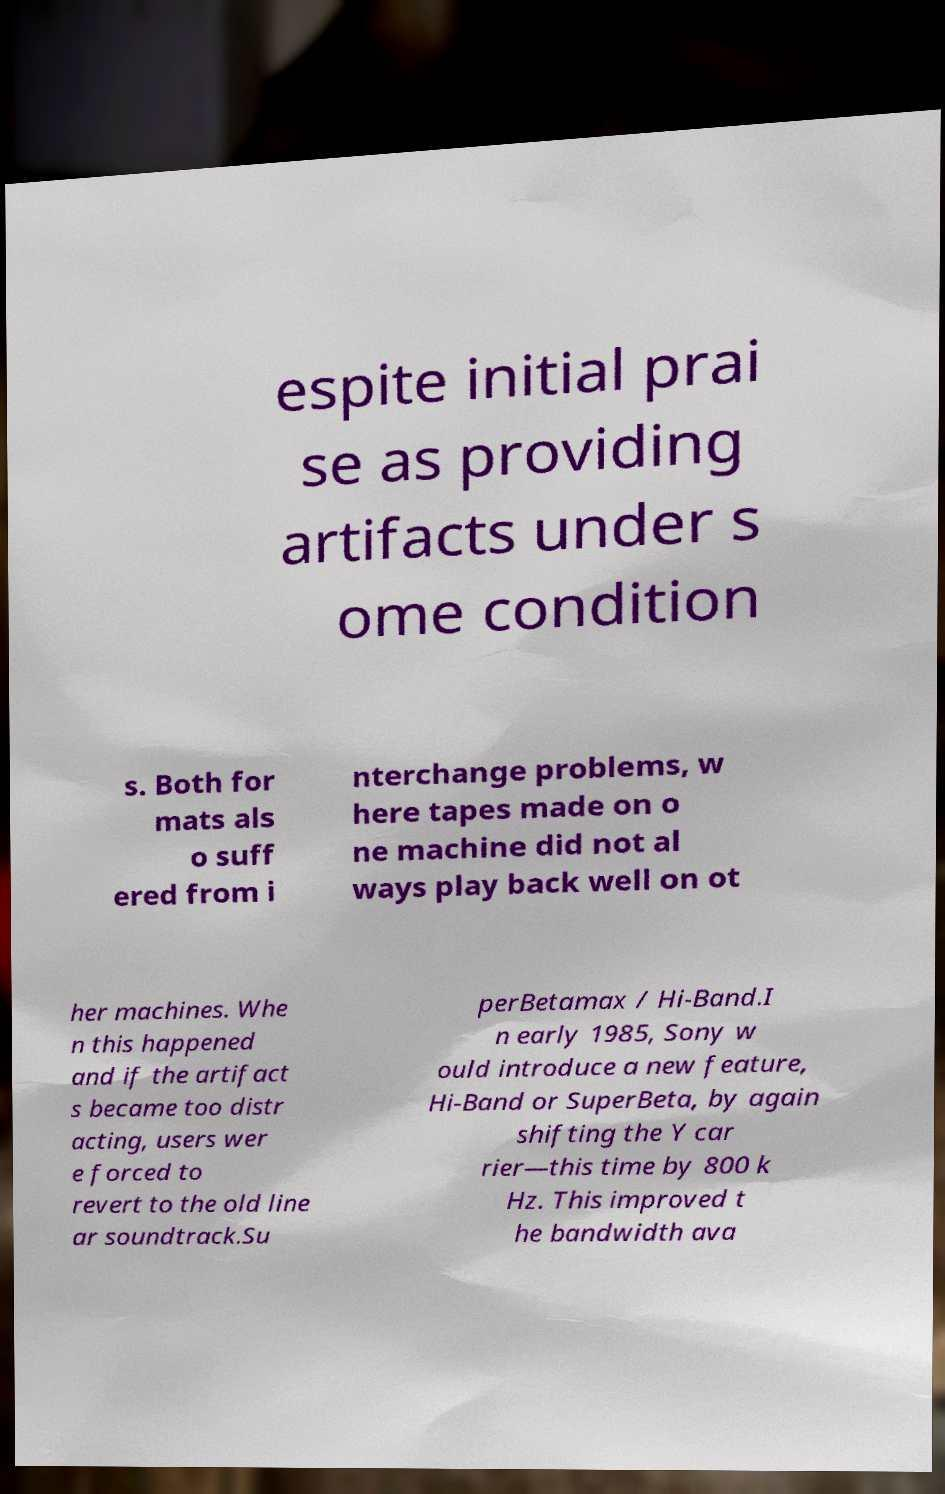Please read and relay the text visible in this image. What does it say? espite initial prai se as providing artifacts under s ome condition s. Both for mats als o suff ered from i nterchange problems, w here tapes made on o ne machine did not al ways play back well on ot her machines. Whe n this happened and if the artifact s became too distr acting, users wer e forced to revert to the old line ar soundtrack.Su perBetamax / Hi-Band.I n early 1985, Sony w ould introduce a new feature, Hi-Band or SuperBeta, by again shifting the Y car rier—this time by 800 k Hz. This improved t he bandwidth ava 